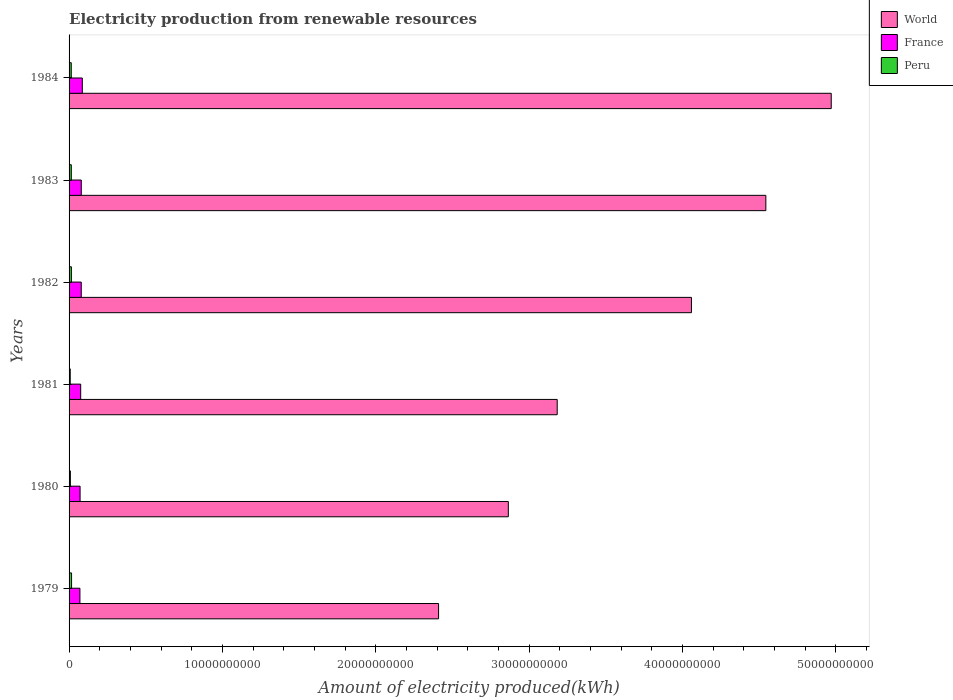How many different coloured bars are there?
Provide a short and direct response. 3. How many bars are there on the 4th tick from the bottom?
Your answer should be very brief. 3. In how many cases, is the number of bars for a given year not equal to the number of legend labels?
Offer a terse response. 0. What is the amount of electricity produced in World in 1984?
Offer a terse response. 4.97e+1. Across all years, what is the maximum amount of electricity produced in France?
Make the answer very short. 8.64e+08. Across all years, what is the minimum amount of electricity produced in Peru?
Provide a short and direct response. 7.60e+07. In which year was the amount of electricity produced in World minimum?
Give a very brief answer. 1979. What is the total amount of electricity produced in World in the graph?
Keep it short and to the point. 2.20e+11. What is the difference between the amount of electricity produced in France in 1981 and that in 1982?
Provide a short and direct response. -3.60e+07. What is the difference between the amount of electricity produced in World in 1984 and the amount of electricity produced in France in 1982?
Your response must be concise. 4.89e+1. What is the average amount of electricity produced in France per year?
Make the answer very short. 7.73e+08. In the year 1981, what is the difference between the amount of electricity produced in Peru and amount of electricity produced in World?
Provide a short and direct response. -3.18e+1. What is the ratio of the amount of electricity produced in World in 1980 to that in 1984?
Offer a terse response. 0.58. What is the difference between the highest and the second highest amount of electricity produced in World?
Provide a short and direct response. 4.26e+09. What is the difference between the highest and the lowest amount of electricity produced in World?
Keep it short and to the point. 2.56e+1. In how many years, is the amount of electricity produced in Peru greater than the average amount of electricity produced in Peru taken over all years?
Your response must be concise. 4. Is the sum of the amount of electricity produced in Peru in 1979 and 1981 greater than the maximum amount of electricity produced in France across all years?
Keep it short and to the point. No. What does the 2nd bar from the bottom in 1980 represents?
Your answer should be very brief. France. Is it the case that in every year, the sum of the amount of electricity produced in Peru and amount of electricity produced in France is greater than the amount of electricity produced in World?
Keep it short and to the point. No. How many bars are there?
Provide a succinct answer. 18. How many years are there in the graph?
Provide a succinct answer. 6. What is the difference between two consecutive major ticks on the X-axis?
Offer a terse response. 1.00e+1. Where does the legend appear in the graph?
Offer a terse response. Top right. What is the title of the graph?
Make the answer very short. Electricity production from renewable resources. Does "Europe(developing only)" appear as one of the legend labels in the graph?
Give a very brief answer. No. What is the label or title of the X-axis?
Provide a short and direct response. Amount of electricity produced(kWh). What is the Amount of electricity produced(kWh) in World in 1979?
Your answer should be very brief. 2.41e+1. What is the Amount of electricity produced(kWh) of France in 1979?
Provide a succinct answer. 7.08e+08. What is the Amount of electricity produced(kWh) in Peru in 1979?
Offer a terse response. 1.63e+08. What is the Amount of electricity produced(kWh) in World in 1980?
Give a very brief answer. 2.86e+1. What is the Amount of electricity produced(kWh) in France in 1980?
Ensure brevity in your answer.  7.18e+08. What is the Amount of electricity produced(kWh) of Peru in 1980?
Keep it short and to the point. 8.50e+07. What is the Amount of electricity produced(kWh) in World in 1981?
Give a very brief answer. 3.18e+1. What is the Amount of electricity produced(kWh) in France in 1981?
Your answer should be compact. 7.58e+08. What is the Amount of electricity produced(kWh) of Peru in 1981?
Offer a very short reply. 7.60e+07. What is the Amount of electricity produced(kWh) in World in 1982?
Provide a short and direct response. 4.06e+1. What is the Amount of electricity produced(kWh) of France in 1982?
Ensure brevity in your answer.  7.94e+08. What is the Amount of electricity produced(kWh) of Peru in 1982?
Offer a very short reply. 1.51e+08. What is the Amount of electricity produced(kWh) in World in 1983?
Give a very brief answer. 4.54e+1. What is the Amount of electricity produced(kWh) of France in 1983?
Give a very brief answer. 7.96e+08. What is the Amount of electricity produced(kWh) of Peru in 1983?
Provide a succinct answer. 1.45e+08. What is the Amount of electricity produced(kWh) in World in 1984?
Your answer should be compact. 4.97e+1. What is the Amount of electricity produced(kWh) of France in 1984?
Your response must be concise. 8.64e+08. What is the Amount of electricity produced(kWh) of Peru in 1984?
Provide a short and direct response. 1.42e+08. Across all years, what is the maximum Amount of electricity produced(kWh) in World?
Your answer should be compact. 4.97e+1. Across all years, what is the maximum Amount of electricity produced(kWh) of France?
Your answer should be very brief. 8.64e+08. Across all years, what is the maximum Amount of electricity produced(kWh) of Peru?
Your response must be concise. 1.63e+08. Across all years, what is the minimum Amount of electricity produced(kWh) of World?
Your answer should be compact. 2.41e+1. Across all years, what is the minimum Amount of electricity produced(kWh) in France?
Your answer should be compact. 7.08e+08. Across all years, what is the minimum Amount of electricity produced(kWh) of Peru?
Ensure brevity in your answer.  7.60e+07. What is the total Amount of electricity produced(kWh) of World in the graph?
Keep it short and to the point. 2.20e+11. What is the total Amount of electricity produced(kWh) in France in the graph?
Your answer should be compact. 4.64e+09. What is the total Amount of electricity produced(kWh) of Peru in the graph?
Give a very brief answer. 7.62e+08. What is the difference between the Amount of electricity produced(kWh) in World in 1979 and that in 1980?
Make the answer very short. -4.55e+09. What is the difference between the Amount of electricity produced(kWh) in France in 1979 and that in 1980?
Provide a succinct answer. -1.00e+07. What is the difference between the Amount of electricity produced(kWh) of Peru in 1979 and that in 1980?
Your response must be concise. 7.80e+07. What is the difference between the Amount of electricity produced(kWh) of World in 1979 and that in 1981?
Ensure brevity in your answer.  -7.74e+09. What is the difference between the Amount of electricity produced(kWh) of France in 1979 and that in 1981?
Your answer should be compact. -5.00e+07. What is the difference between the Amount of electricity produced(kWh) in Peru in 1979 and that in 1981?
Provide a succinct answer. 8.70e+07. What is the difference between the Amount of electricity produced(kWh) of World in 1979 and that in 1982?
Make the answer very short. -1.65e+1. What is the difference between the Amount of electricity produced(kWh) of France in 1979 and that in 1982?
Offer a terse response. -8.60e+07. What is the difference between the Amount of electricity produced(kWh) of World in 1979 and that in 1983?
Ensure brevity in your answer.  -2.13e+1. What is the difference between the Amount of electricity produced(kWh) of France in 1979 and that in 1983?
Your response must be concise. -8.80e+07. What is the difference between the Amount of electricity produced(kWh) in Peru in 1979 and that in 1983?
Keep it short and to the point. 1.80e+07. What is the difference between the Amount of electricity produced(kWh) in World in 1979 and that in 1984?
Keep it short and to the point. -2.56e+1. What is the difference between the Amount of electricity produced(kWh) in France in 1979 and that in 1984?
Ensure brevity in your answer.  -1.56e+08. What is the difference between the Amount of electricity produced(kWh) in Peru in 1979 and that in 1984?
Make the answer very short. 2.10e+07. What is the difference between the Amount of electricity produced(kWh) of World in 1980 and that in 1981?
Provide a succinct answer. -3.19e+09. What is the difference between the Amount of electricity produced(kWh) of France in 1980 and that in 1981?
Provide a succinct answer. -4.00e+07. What is the difference between the Amount of electricity produced(kWh) in Peru in 1980 and that in 1981?
Your answer should be very brief. 9.00e+06. What is the difference between the Amount of electricity produced(kWh) in World in 1980 and that in 1982?
Offer a very short reply. -1.19e+1. What is the difference between the Amount of electricity produced(kWh) of France in 1980 and that in 1982?
Make the answer very short. -7.60e+07. What is the difference between the Amount of electricity produced(kWh) in Peru in 1980 and that in 1982?
Provide a short and direct response. -6.60e+07. What is the difference between the Amount of electricity produced(kWh) of World in 1980 and that in 1983?
Your answer should be compact. -1.68e+1. What is the difference between the Amount of electricity produced(kWh) in France in 1980 and that in 1983?
Keep it short and to the point. -7.80e+07. What is the difference between the Amount of electricity produced(kWh) in Peru in 1980 and that in 1983?
Provide a short and direct response. -6.00e+07. What is the difference between the Amount of electricity produced(kWh) in World in 1980 and that in 1984?
Your response must be concise. -2.11e+1. What is the difference between the Amount of electricity produced(kWh) in France in 1980 and that in 1984?
Your answer should be compact. -1.46e+08. What is the difference between the Amount of electricity produced(kWh) of Peru in 1980 and that in 1984?
Ensure brevity in your answer.  -5.70e+07. What is the difference between the Amount of electricity produced(kWh) of World in 1981 and that in 1982?
Give a very brief answer. -8.76e+09. What is the difference between the Amount of electricity produced(kWh) of France in 1981 and that in 1982?
Offer a terse response. -3.60e+07. What is the difference between the Amount of electricity produced(kWh) of Peru in 1981 and that in 1982?
Provide a short and direct response. -7.50e+07. What is the difference between the Amount of electricity produced(kWh) of World in 1981 and that in 1983?
Keep it short and to the point. -1.36e+1. What is the difference between the Amount of electricity produced(kWh) of France in 1981 and that in 1983?
Provide a short and direct response. -3.80e+07. What is the difference between the Amount of electricity produced(kWh) in Peru in 1981 and that in 1983?
Offer a terse response. -6.90e+07. What is the difference between the Amount of electricity produced(kWh) of World in 1981 and that in 1984?
Give a very brief answer. -1.79e+1. What is the difference between the Amount of electricity produced(kWh) of France in 1981 and that in 1984?
Your answer should be very brief. -1.06e+08. What is the difference between the Amount of electricity produced(kWh) of Peru in 1981 and that in 1984?
Your response must be concise. -6.60e+07. What is the difference between the Amount of electricity produced(kWh) of World in 1982 and that in 1983?
Provide a short and direct response. -4.85e+09. What is the difference between the Amount of electricity produced(kWh) in France in 1982 and that in 1983?
Ensure brevity in your answer.  -2.00e+06. What is the difference between the Amount of electricity produced(kWh) in World in 1982 and that in 1984?
Your response must be concise. -9.12e+09. What is the difference between the Amount of electricity produced(kWh) in France in 1982 and that in 1984?
Provide a short and direct response. -7.00e+07. What is the difference between the Amount of electricity produced(kWh) of Peru in 1982 and that in 1984?
Provide a short and direct response. 9.00e+06. What is the difference between the Amount of electricity produced(kWh) of World in 1983 and that in 1984?
Your response must be concise. -4.26e+09. What is the difference between the Amount of electricity produced(kWh) in France in 1983 and that in 1984?
Offer a terse response. -6.80e+07. What is the difference between the Amount of electricity produced(kWh) of World in 1979 and the Amount of electricity produced(kWh) of France in 1980?
Ensure brevity in your answer.  2.34e+1. What is the difference between the Amount of electricity produced(kWh) of World in 1979 and the Amount of electricity produced(kWh) of Peru in 1980?
Your answer should be compact. 2.40e+1. What is the difference between the Amount of electricity produced(kWh) of France in 1979 and the Amount of electricity produced(kWh) of Peru in 1980?
Give a very brief answer. 6.23e+08. What is the difference between the Amount of electricity produced(kWh) of World in 1979 and the Amount of electricity produced(kWh) of France in 1981?
Ensure brevity in your answer.  2.33e+1. What is the difference between the Amount of electricity produced(kWh) in World in 1979 and the Amount of electricity produced(kWh) in Peru in 1981?
Your answer should be compact. 2.40e+1. What is the difference between the Amount of electricity produced(kWh) of France in 1979 and the Amount of electricity produced(kWh) of Peru in 1981?
Offer a very short reply. 6.32e+08. What is the difference between the Amount of electricity produced(kWh) in World in 1979 and the Amount of electricity produced(kWh) in France in 1982?
Give a very brief answer. 2.33e+1. What is the difference between the Amount of electricity produced(kWh) in World in 1979 and the Amount of electricity produced(kWh) in Peru in 1982?
Give a very brief answer. 2.39e+1. What is the difference between the Amount of electricity produced(kWh) of France in 1979 and the Amount of electricity produced(kWh) of Peru in 1982?
Offer a terse response. 5.57e+08. What is the difference between the Amount of electricity produced(kWh) of World in 1979 and the Amount of electricity produced(kWh) of France in 1983?
Offer a terse response. 2.33e+1. What is the difference between the Amount of electricity produced(kWh) of World in 1979 and the Amount of electricity produced(kWh) of Peru in 1983?
Your response must be concise. 2.40e+1. What is the difference between the Amount of electricity produced(kWh) of France in 1979 and the Amount of electricity produced(kWh) of Peru in 1983?
Keep it short and to the point. 5.63e+08. What is the difference between the Amount of electricity produced(kWh) in World in 1979 and the Amount of electricity produced(kWh) in France in 1984?
Provide a short and direct response. 2.32e+1. What is the difference between the Amount of electricity produced(kWh) in World in 1979 and the Amount of electricity produced(kWh) in Peru in 1984?
Make the answer very short. 2.40e+1. What is the difference between the Amount of electricity produced(kWh) of France in 1979 and the Amount of electricity produced(kWh) of Peru in 1984?
Provide a short and direct response. 5.66e+08. What is the difference between the Amount of electricity produced(kWh) of World in 1980 and the Amount of electricity produced(kWh) of France in 1981?
Offer a very short reply. 2.79e+1. What is the difference between the Amount of electricity produced(kWh) in World in 1980 and the Amount of electricity produced(kWh) in Peru in 1981?
Give a very brief answer. 2.86e+1. What is the difference between the Amount of electricity produced(kWh) of France in 1980 and the Amount of electricity produced(kWh) of Peru in 1981?
Your response must be concise. 6.42e+08. What is the difference between the Amount of electricity produced(kWh) of World in 1980 and the Amount of electricity produced(kWh) of France in 1982?
Offer a terse response. 2.79e+1. What is the difference between the Amount of electricity produced(kWh) in World in 1980 and the Amount of electricity produced(kWh) in Peru in 1982?
Offer a terse response. 2.85e+1. What is the difference between the Amount of electricity produced(kWh) in France in 1980 and the Amount of electricity produced(kWh) in Peru in 1982?
Your answer should be very brief. 5.67e+08. What is the difference between the Amount of electricity produced(kWh) in World in 1980 and the Amount of electricity produced(kWh) in France in 1983?
Your response must be concise. 2.79e+1. What is the difference between the Amount of electricity produced(kWh) in World in 1980 and the Amount of electricity produced(kWh) in Peru in 1983?
Keep it short and to the point. 2.85e+1. What is the difference between the Amount of electricity produced(kWh) in France in 1980 and the Amount of electricity produced(kWh) in Peru in 1983?
Your response must be concise. 5.73e+08. What is the difference between the Amount of electricity produced(kWh) of World in 1980 and the Amount of electricity produced(kWh) of France in 1984?
Keep it short and to the point. 2.78e+1. What is the difference between the Amount of electricity produced(kWh) of World in 1980 and the Amount of electricity produced(kWh) of Peru in 1984?
Offer a very short reply. 2.85e+1. What is the difference between the Amount of electricity produced(kWh) of France in 1980 and the Amount of electricity produced(kWh) of Peru in 1984?
Offer a terse response. 5.76e+08. What is the difference between the Amount of electricity produced(kWh) in World in 1981 and the Amount of electricity produced(kWh) in France in 1982?
Your answer should be compact. 3.10e+1. What is the difference between the Amount of electricity produced(kWh) in World in 1981 and the Amount of electricity produced(kWh) in Peru in 1982?
Provide a short and direct response. 3.17e+1. What is the difference between the Amount of electricity produced(kWh) of France in 1981 and the Amount of electricity produced(kWh) of Peru in 1982?
Your answer should be compact. 6.07e+08. What is the difference between the Amount of electricity produced(kWh) in World in 1981 and the Amount of electricity produced(kWh) in France in 1983?
Give a very brief answer. 3.10e+1. What is the difference between the Amount of electricity produced(kWh) in World in 1981 and the Amount of electricity produced(kWh) in Peru in 1983?
Make the answer very short. 3.17e+1. What is the difference between the Amount of electricity produced(kWh) in France in 1981 and the Amount of electricity produced(kWh) in Peru in 1983?
Give a very brief answer. 6.13e+08. What is the difference between the Amount of electricity produced(kWh) of World in 1981 and the Amount of electricity produced(kWh) of France in 1984?
Provide a short and direct response. 3.10e+1. What is the difference between the Amount of electricity produced(kWh) in World in 1981 and the Amount of electricity produced(kWh) in Peru in 1984?
Provide a succinct answer. 3.17e+1. What is the difference between the Amount of electricity produced(kWh) in France in 1981 and the Amount of electricity produced(kWh) in Peru in 1984?
Provide a short and direct response. 6.16e+08. What is the difference between the Amount of electricity produced(kWh) in World in 1982 and the Amount of electricity produced(kWh) in France in 1983?
Your answer should be compact. 3.98e+1. What is the difference between the Amount of electricity produced(kWh) in World in 1982 and the Amount of electricity produced(kWh) in Peru in 1983?
Make the answer very short. 4.04e+1. What is the difference between the Amount of electricity produced(kWh) in France in 1982 and the Amount of electricity produced(kWh) in Peru in 1983?
Offer a terse response. 6.49e+08. What is the difference between the Amount of electricity produced(kWh) of World in 1982 and the Amount of electricity produced(kWh) of France in 1984?
Offer a very short reply. 3.97e+1. What is the difference between the Amount of electricity produced(kWh) of World in 1982 and the Amount of electricity produced(kWh) of Peru in 1984?
Offer a very short reply. 4.04e+1. What is the difference between the Amount of electricity produced(kWh) of France in 1982 and the Amount of electricity produced(kWh) of Peru in 1984?
Offer a very short reply. 6.52e+08. What is the difference between the Amount of electricity produced(kWh) of World in 1983 and the Amount of electricity produced(kWh) of France in 1984?
Give a very brief answer. 4.46e+1. What is the difference between the Amount of electricity produced(kWh) in World in 1983 and the Amount of electricity produced(kWh) in Peru in 1984?
Ensure brevity in your answer.  4.53e+1. What is the difference between the Amount of electricity produced(kWh) of France in 1983 and the Amount of electricity produced(kWh) of Peru in 1984?
Your answer should be compact. 6.54e+08. What is the average Amount of electricity produced(kWh) of World per year?
Offer a very short reply. 3.67e+1. What is the average Amount of electricity produced(kWh) in France per year?
Provide a short and direct response. 7.73e+08. What is the average Amount of electricity produced(kWh) of Peru per year?
Your answer should be very brief. 1.27e+08. In the year 1979, what is the difference between the Amount of electricity produced(kWh) in World and Amount of electricity produced(kWh) in France?
Make the answer very short. 2.34e+1. In the year 1979, what is the difference between the Amount of electricity produced(kWh) in World and Amount of electricity produced(kWh) in Peru?
Keep it short and to the point. 2.39e+1. In the year 1979, what is the difference between the Amount of electricity produced(kWh) in France and Amount of electricity produced(kWh) in Peru?
Make the answer very short. 5.45e+08. In the year 1980, what is the difference between the Amount of electricity produced(kWh) in World and Amount of electricity produced(kWh) in France?
Your answer should be compact. 2.79e+1. In the year 1980, what is the difference between the Amount of electricity produced(kWh) of World and Amount of electricity produced(kWh) of Peru?
Provide a succinct answer. 2.86e+1. In the year 1980, what is the difference between the Amount of electricity produced(kWh) of France and Amount of electricity produced(kWh) of Peru?
Offer a very short reply. 6.33e+08. In the year 1981, what is the difference between the Amount of electricity produced(kWh) in World and Amount of electricity produced(kWh) in France?
Offer a very short reply. 3.11e+1. In the year 1981, what is the difference between the Amount of electricity produced(kWh) in World and Amount of electricity produced(kWh) in Peru?
Ensure brevity in your answer.  3.18e+1. In the year 1981, what is the difference between the Amount of electricity produced(kWh) in France and Amount of electricity produced(kWh) in Peru?
Your response must be concise. 6.82e+08. In the year 1982, what is the difference between the Amount of electricity produced(kWh) in World and Amount of electricity produced(kWh) in France?
Offer a very short reply. 3.98e+1. In the year 1982, what is the difference between the Amount of electricity produced(kWh) of World and Amount of electricity produced(kWh) of Peru?
Give a very brief answer. 4.04e+1. In the year 1982, what is the difference between the Amount of electricity produced(kWh) of France and Amount of electricity produced(kWh) of Peru?
Provide a short and direct response. 6.43e+08. In the year 1983, what is the difference between the Amount of electricity produced(kWh) of World and Amount of electricity produced(kWh) of France?
Make the answer very short. 4.46e+1. In the year 1983, what is the difference between the Amount of electricity produced(kWh) of World and Amount of electricity produced(kWh) of Peru?
Ensure brevity in your answer.  4.53e+1. In the year 1983, what is the difference between the Amount of electricity produced(kWh) of France and Amount of electricity produced(kWh) of Peru?
Your answer should be very brief. 6.51e+08. In the year 1984, what is the difference between the Amount of electricity produced(kWh) of World and Amount of electricity produced(kWh) of France?
Provide a short and direct response. 4.88e+1. In the year 1984, what is the difference between the Amount of electricity produced(kWh) in World and Amount of electricity produced(kWh) in Peru?
Your response must be concise. 4.96e+1. In the year 1984, what is the difference between the Amount of electricity produced(kWh) of France and Amount of electricity produced(kWh) of Peru?
Provide a succinct answer. 7.22e+08. What is the ratio of the Amount of electricity produced(kWh) of World in 1979 to that in 1980?
Provide a short and direct response. 0.84. What is the ratio of the Amount of electricity produced(kWh) of France in 1979 to that in 1980?
Provide a succinct answer. 0.99. What is the ratio of the Amount of electricity produced(kWh) in Peru in 1979 to that in 1980?
Your answer should be very brief. 1.92. What is the ratio of the Amount of electricity produced(kWh) in World in 1979 to that in 1981?
Your response must be concise. 0.76. What is the ratio of the Amount of electricity produced(kWh) in France in 1979 to that in 1981?
Your response must be concise. 0.93. What is the ratio of the Amount of electricity produced(kWh) of Peru in 1979 to that in 1981?
Your answer should be compact. 2.14. What is the ratio of the Amount of electricity produced(kWh) in World in 1979 to that in 1982?
Provide a succinct answer. 0.59. What is the ratio of the Amount of electricity produced(kWh) of France in 1979 to that in 1982?
Give a very brief answer. 0.89. What is the ratio of the Amount of electricity produced(kWh) in Peru in 1979 to that in 1982?
Provide a short and direct response. 1.08. What is the ratio of the Amount of electricity produced(kWh) in World in 1979 to that in 1983?
Provide a succinct answer. 0.53. What is the ratio of the Amount of electricity produced(kWh) of France in 1979 to that in 1983?
Give a very brief answer. 0.89. What is the ratio of the Amount of electricity produced(kWh) of Peru in 1979 to that in 1983?
Provide a succinct answer. 1.12. What is the ratio of the Amount of electricity produced(kWh) of World in 1979 to that in 1984?
Provide a short and direct response. 0.48. What is the ratio of the Amount of electricity produced(kWh) in France in 1979 to that in 1984?
Your response must be concise. 0.82. What is the ratio of the Amount of electricity produced(kWh) in Peru in 1979 to that in 1984?
Make the answer very short. 1.15. What is the ratio of the Amount of electricity produced(kWh) in World in 1980 to that in 1981?
Your response must be concise. 0.9. What is the ratio of the Amount of electricity produced(kWh) in France in 1980 to that in 1981?
Offer a very short reply. 0.95. What is the ratio of the Amount of electricity produced(kWh) of Peru in 1980 to that in 1981?
Your answer should be very brief. 1.12. What is the ratio of the Amount of electricity produced(kWh) in World in 1980 to that in 1982?
Offer a terse response. 0.71. What is the ratio of the Amount of electricity produced(kWh) of France in 1980 to that in 1982?
Ensure brevity in your answer.  0.9. What is the ratio of the Amount of electricity produced(kWh) of Peru in 1980 to that in 1982?
Provide a succinct answer. 0.56. What is the ratio of the Amount of electricity produced(kWh) in World in 1980 to that in 1983?
Your answer should be compact. 0.63. What is the ratio of the Amount of electricity produced(kWh) in France in 1980 to that in 1983?
Provide a short and direct response. 0.9. What is the ratio of the Amount of electricity produced(kWh) of Peru in 1980 to that in 1983?
Your response must be concise. 0.59. What is the ratio of the Amount of electricity produced(kWh) of World in 1980 to that in 1984?
Your response must be concise. 0.58. What is the ratio of the Amount of electricity produced(kWh) of France in 1980 to that in 1984?
Provide a short and direct response. 0.83. What is the ratio of the Amount of electricity produced(kWh) of Peru in 1980 to that in 1984?
Your response must be concise. 0.6. What is the ratio of the Amount of electricity produced(kWh) of World in 1981 to that in 1982?
Ensure brevity in your answer.  0.78. What is the ratio of the Amount of electricity produced(kWh) of France in 1981 to that in 1982?
Provide a succinct answer. 0.95. What is the ratio of the Amount of electricity produced(kWh) in Peru in 1981 to that in 1982?
Provide a succinct answer. 0.5. What is the ratio of the Amount of electricity produced(kWh) in World in 1981 to that in 1983?
Your answer should be compact. 0.7. What is the ratio of the Amount of electricity produced(kWh) in France in 1981 to that in 1983?
Make the answer very short. 0.95. What is the ratio of the Amount of electricity produced(kWh) in Peru in 1981 to that in 1983?
Offer a very short reply. 0.52. What is the ratio of the Amount of electricity produced(kWh) in World in 1981 to that in 1984?
Provide a succinct answer. 0.64. What is the ratio of the Amount of electricity produced(kWh) in France in 1981 to that in 1984?
Your answer should be compact. 0.88. What is the ratio of the Amount of electricity produced(kWh) in Peru in 1981 to that in 1984?
Offer a terse response. 0.54. What is the ratio of the Amount of electricity produced(kWh) in World in 1982 to that in 1983?
Keep it short and to the point. 0.89. What is the ratio of the Amount of electricity produced(kWh) of Peru in 1982 to that in 1983?
Provide a succinct answer. 1.04. What is the ratio of the Amount of electricity produced(kWh) of World in 1982 to that in 1984?
Your answer should be very brief. 0.82. What is the ratio of the Amount of electricity produced(kWh) of France in 1982 to that in 1984?
Give a very brief answer. 0.92. What is the ratio of the Amount of electricity produced(kWh) in Peru in 1982 to that in 1984?
Keep it short and to the point. 1.06. What is the ratio of the Amount of electricity produced(kWh) of World in 1983 to that in 1984?
Your answer should be very brief. 0.91. What is the ratio of the Amount of electricity produced(kWh) in France in 1983 to that in 1984?
Offer a very short reply. 0.92. What is the ratio of the Amount of electricity produced(kWh) in Peru in 1983 to that in 1984?
Ensure brevity in your answer.  1.02. What is the difference between the highest and the second highest Amount of electricity produced(kWh) in World?
Provide a short and direct response. 4.26e+09. What is the difference between the highest and the second highest Amount of electricity produced(kWh) in France?
Provide a short and direct response. 6.80e+07. What is the difference between the highest and the second highest Amount of electricity produced(kWh) of Peru?
Your response must be concise. 1.20e+07. What is the difference between the highest and the lowest Amount of electricity produced(kWh) of World?
Your answer should be compact. 2.56e+1. What is the difference between the highest and the lowest Amount of electricity produced(kWh) in France?
Your answer should be very brief. 1.56e+08. What is the difference between the highest and the lowest Amount of electricity produced(kWh) of Peru?
Your answer should be compact. 8.70e+07. 